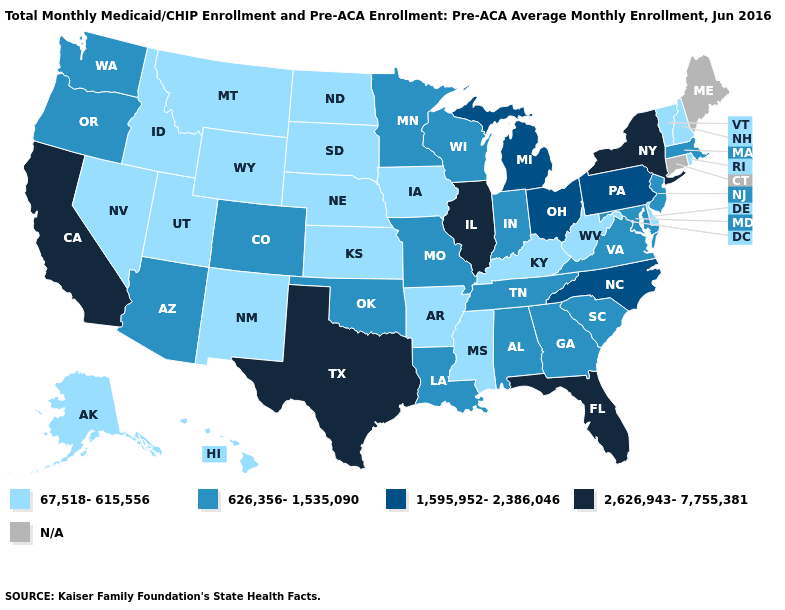What is the value of Wyoming?
Quick response, please. 67,518-615,556. Which states have the highest value in the USA?
Concise answer only. California, Florida, Illinois, New York, Texas. Among the states that border Louisiana , does Texas have the highest value?
Quick response, please. Yes. Does Arkansas have the lowest value in the USA?
Write a very short answer. Yes. Name the states that have a value in the range 67,518-615,556?
Quick response, please. Alaska, Arkansas, Delaware, Hawaii, Idaho, Iowa, Kansas, Kentucky, Mississippi, Montana, Nebraska, Nevada, New Hampshire, New Mexico, North Dakota, Rhode Island, South Dakota, Utah, Vermont, West Virginia, Wyoming. Does Pennsylvania have the highest value in the USA?
Short answer required. No. What is the lowest value in states that border South Dakota?
Give a very brief answer. 67,518-615,556. What is the value of South Carolina?
Write a very short answer. 626,356-1,535,090. What is the lowest value in the West?
Quick response, please. 67,518-615,556. What is the value of Kansas?
Short answer required. 67,518-615,556. What is the highest value in the USA?
Write a very short answer. 2,626,943-7,755,381. What is the value of Oregon?
Keep it brief. 626,356-1,535,090. What is the value of Vermont?
Give a very brief answer. 67,518-615,556. What is the value of Arizona?
Answer briefly. 626,356-1,535,090. 